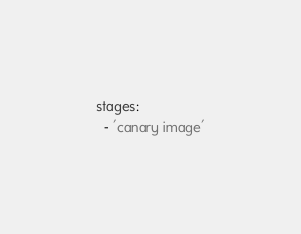<code> <loc_0><loc_0><loc_500><loc_500><_YAML_>stages:
  - 'canary image'
</code> 